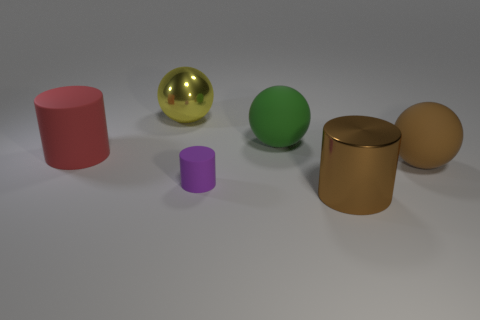What can you infer about the size of the objects? Based on their relative proportions in the image, the golden cylinder appears to be the largest object, followed by the pink cylinder. The green sphere seems to be approximately the same size as the pink cylinder but smaller than the gold one. The yellow sphere, although shiny, is smaller than the green sphere, and the smallest object appears to be the purple cylinder.  Is there a sense of depth or three-dimensionality in the scene? Indeed, there is a sense of depth created by the arrangement of objects and the lighting. The shadows give the impression that the lighting is coming from above, casting varying lengths of shadows that help perceive the spatial relationships between the objects, enhancing the three-dimensionality of the scene. 